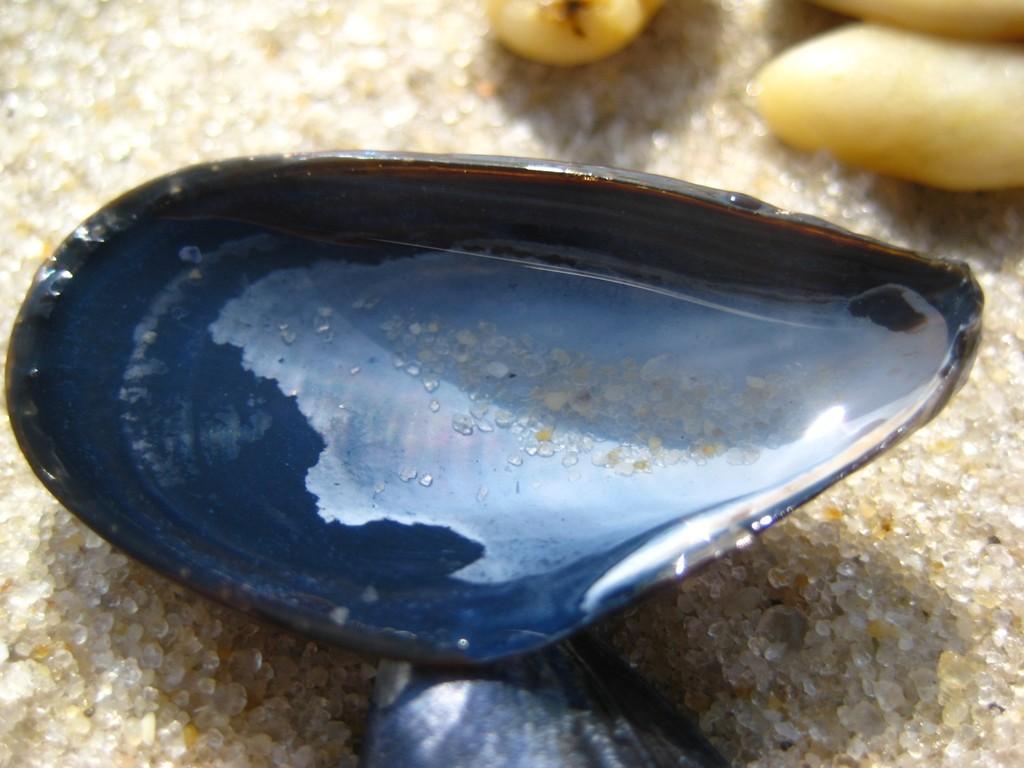Can you describe this image briefly? We can see shell with water and stones on the sand. 